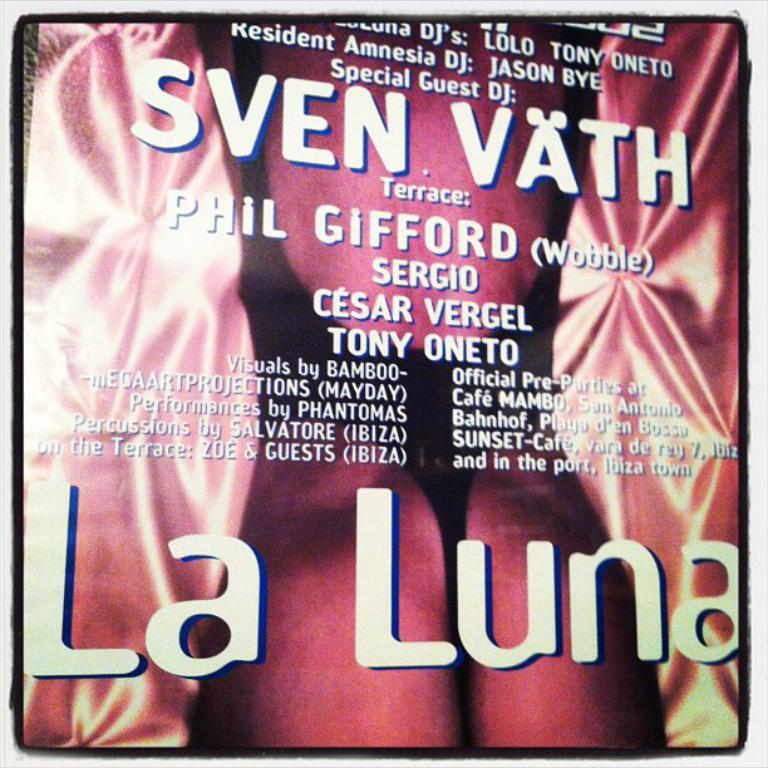Whose name has (wobble) after it?
Make the answer very short. Phil gifford. 